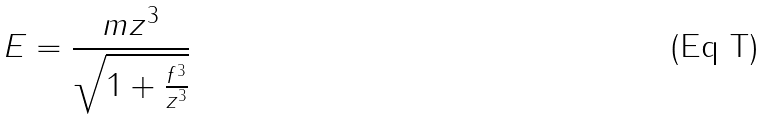Convert formula to latex. <formula><loc_0><loc_0><loc_500><loc_500>E = \frac { m z ^ { 3 } } { \sqrt { 1 + \frac { f ^ { 3 } } { z ^ { 3 } } } }</formula> 